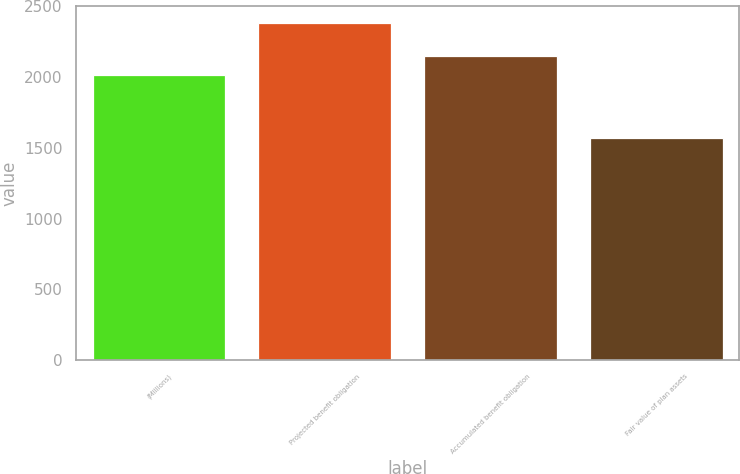Convert chart. <chart><loc_0><loc_0><loc_500><loc_500><bar_chart><fcel>(Millions)<fcel>Projected benefit obligation<fcel>Accumulated benefit obligation<fcel>Fair value of plan assets<nl><fcel>2015<fcel>2382<fcel>2149<fcel>1566<nl></chart> 